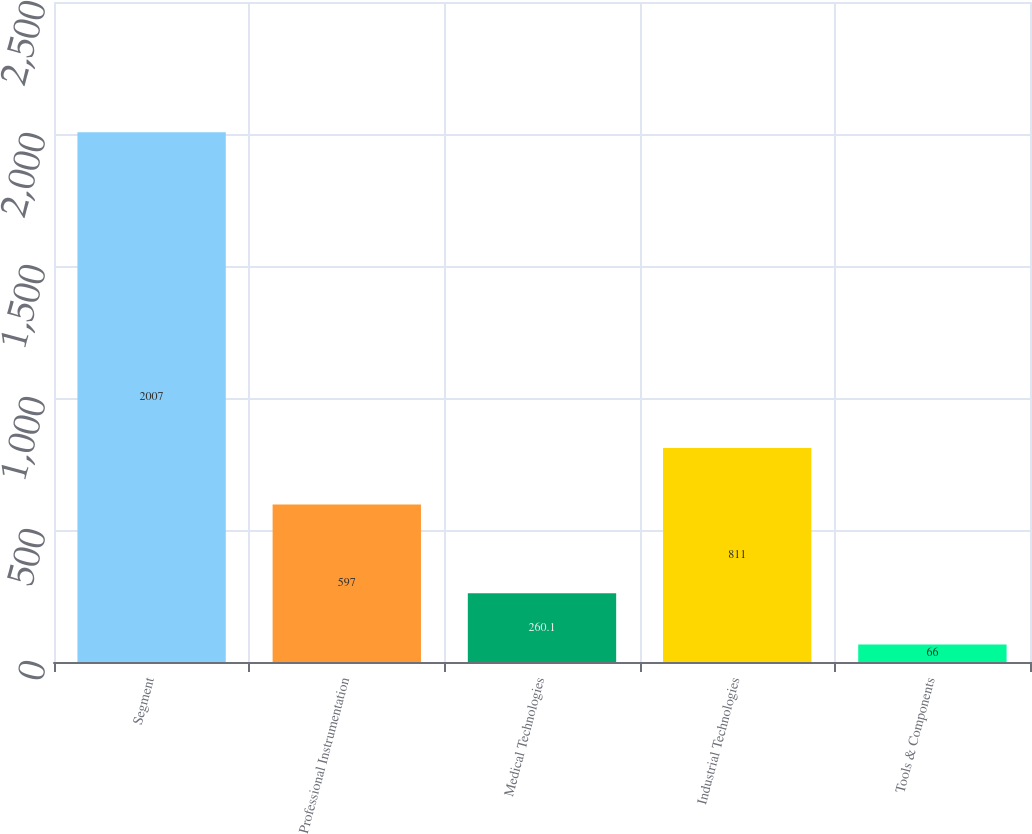<chart> <loc_0><loc_0><loc_500><loc_500><bar_chart><fcel>Segment<fcel>Professional Instrumentation<fcel>Medical Technologies<fcel>Industrial Technologies<fcel>Tools & Components<nl><fcel>2007<fcel>597<fcel>260.1<fcel>811<fcel>66<nl></chart> 